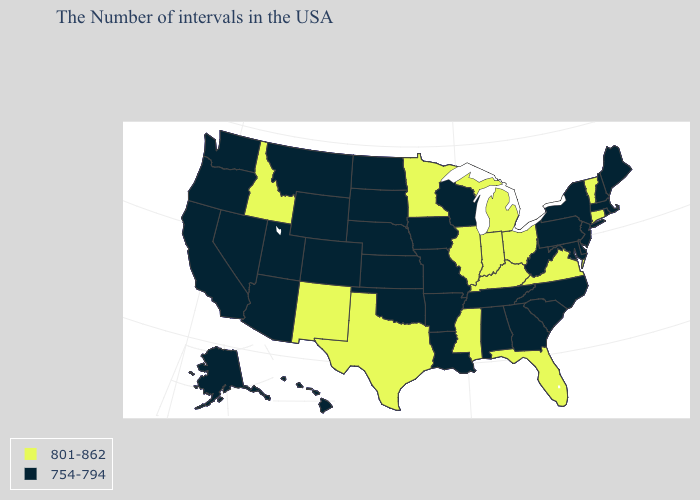What is the value of Virginia?
Write a very short answer. 801-862. What is the highest value in states that border Arizona?
Be succinct. 801-862. Which states have the lowest value in the Northeast?
Answer briefly. Maine, Massachusetts, Rhode Island, New Hampshire, New York, New Jersey, Pennsylvania. What is the value of Iowa?
Be succinct. 754-794. What is the value of Kansas?
Answer briefly. 754-794. Which states hav the highest value in the South?
Write a very short answer. Virginia, Florida, Kentucky, Mississippi, Texas. Does the map have missing data?
Write a very short answer. No. Name the states that have a value in the range 801-862?
Keep it brief. Vermont, Connecticut, Virginia, Ohio, Florida, Michigan, Kentucky, Indiana, Illinois, Mississippi, Minnesota, Texas, New Mexico, Idaho. What is the value of Rhode Island?
Write a very short answer. 754-794. Which states have the highest value in the USA?
Concise answer only. Vermont, Connecticut, Virginia, Ohio, Florida, Michigan, Kentucky, Indiana, Illinois, Mississippi, Minnesota, Texas, New Mexico, Idaho. What is the value of New York?
Short answer required. 754-794. What is the value of Wisconsin?
Keep it brief. 754-794. Name the states that have a value in the range 754-794?
Short answer required. Maine, Massachusetts, Rhode Island, New Hampshire, New York, New Jersey, Delaware, Maryland, Pennsylvania, North Carolina, South Carolina, West Virginia, Georgia, Alabama, Tennessee, Wisconsin, Louisiana, Missouri, Arkansas, Iowa, Kansas, Nebraska, Oklahoma, South Dakota, North Dakota, Wyoming, Colorado, Utah, Montana, Arizona, Nevada, California, Washington, Oregon, Alaska, Hawaii. Does Idaho have the highest value in the West?
Write a very short answer. Yes. What is the highest value in the USA?
Be succinct. 801-862. 